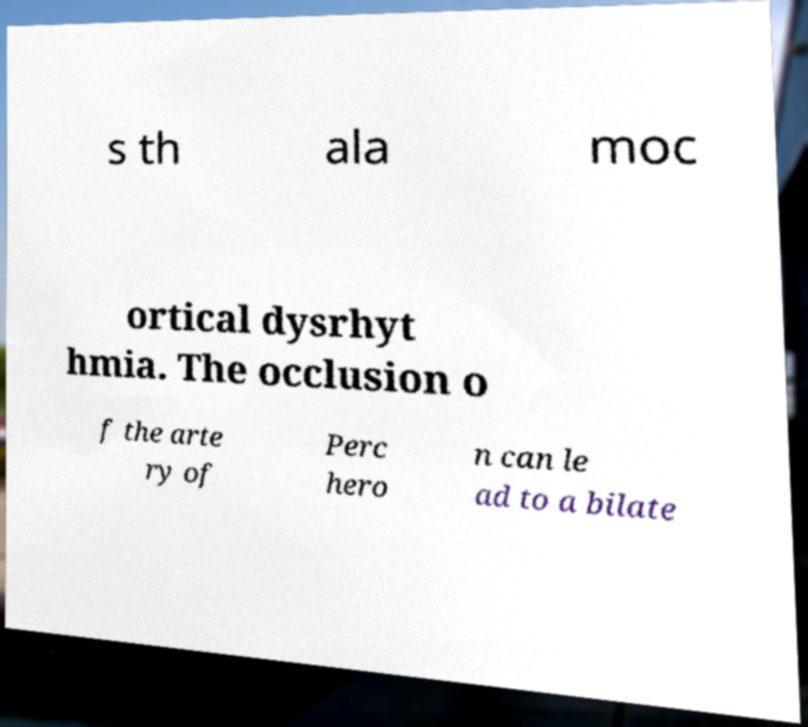Please read and relay the text visible in this image. What does it say? s th ala moc ortical dysrhyt hmia. The occlusion o f the arte ry of Perc hero n can le ad to a bilate 